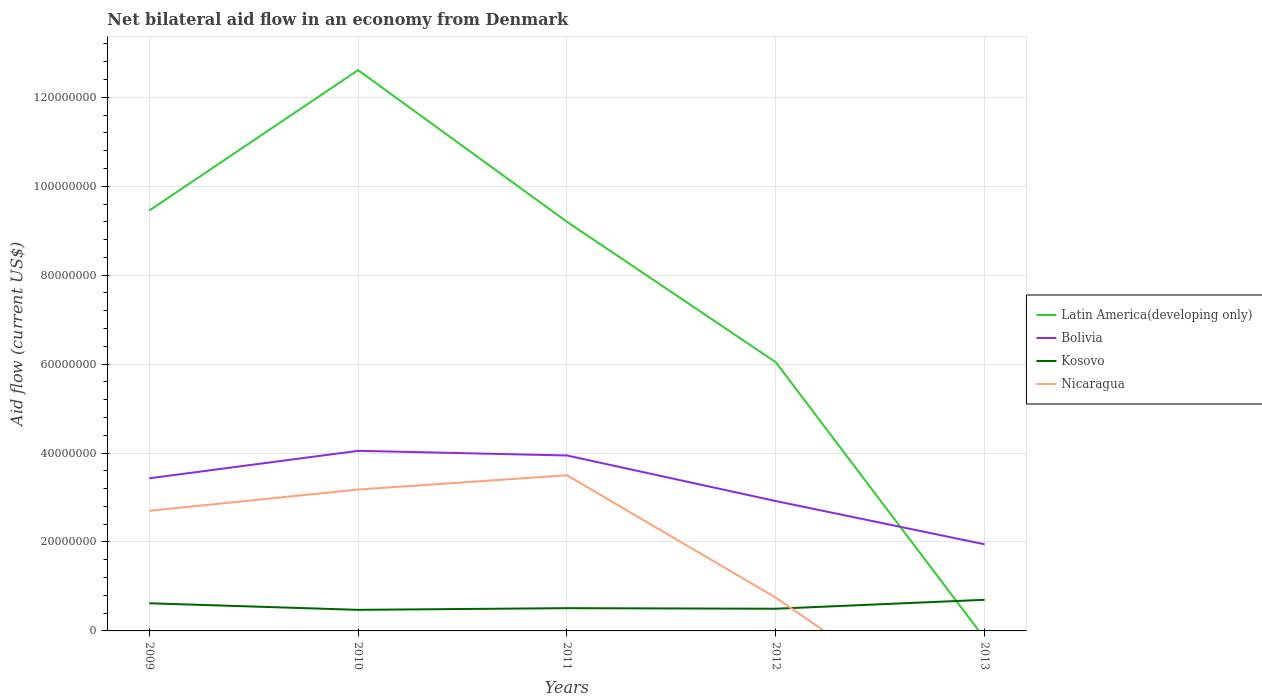Does the line corresponding to Latin America(developing only) intersect with the line corresponding to Nicaragua?
Ensure brevity in your answer.  No. Is the number of lines equal to the number of legend labels?
Your response must be concise. No. Across all years, what is the maximum net bilateral aid flow in Bolivia?
Your response must be concise. 1.95e+07. What is the total net bilateral aid flow in Bolivia in the graph?
Your answer should be compact. 2.00e+07. What is the difference between the highest and the second highest net bilateral aid flow in Kosovo?
Provide a succinct answer. 2.26e+06. What is the difference between the highest and the lowest net bilateral aid flow in Latin America(developing only)?
Offer a terse response. 3. How many lines are there?
Offer a very short reply. 4. How many years are there in the graph?
Offer a terse response. 5. Are the values on the major ticks of Y-axis written in scientific E-notation?
Ensure brevity in your answer.  No. Does the graph contain any zero values?
Offer a very short reply. Yes. How many legend labels are there?
Make the answer very short. 4. How are the legend labels stacked?
Offer a terse response. Vertical. What is the title of the graph?
Your answer should be compact. Net bilateral aid flow in an economy from Denmark. What is the label or title of the X-axis?
Provide a short and direct response. Years. What is the label or title of the Y-axis?
Keep it short and to the point. Aid flow (current US$). What is the Aid flow (current US$) in Latin America(developing only) in 2009?
Ensure brevity in your answer.  9.45e+07. What is the Aid flow (current US$) in Bolivia in 2009?
Your response must be concise. 3.43e+07. What is the Aid flow (current US$) of Kosovo in 2009?
Provide a succinct answer. 6.22e+06. What is the Aid flow (current US$) in Nicaragua in 2009?
Make the answer very short. 2.70e+07. What is the Aid flow (current US$) of Latin America(developing only) in 2010?
Your response must be concise. 1.26e+08. What is the Aid flow (current US$) in Bolivia in 2010?
Give a very brief answer. 4.05e+07. What is the Aid flow (current US$) of Kosovo in 2010?
Make the answer very short. 4.74e+06. What is the Aid flow (current US$) in Nicaragua in 2010?
Offer a very short reply. 3.18e+07. What is the Aid flow (current US$) in Latin America(developing only) in 2011?
Make the answer very short. 9.20e+07. What is the Aid flow (current US$) of Bolivia in 2011?
Your answer should be very brief. 3.94e+07. What is the Aid flow (current US$) of Kosovo in 2011?
Provide a short and direct response. 5.12e+06. What is the Aid flow (current US$) in Nicaragua in 2011?
Make the answer very short. 3.50e+07. What is the Aid flow (current US$) in Latin America(developing only) in 2012?
Provide a succinct answer. 6.04e+07. What is the Aid flow (current US$) of Bolivia in 2012?
Offer a very short reply. 2.92e+07. What is the Aid flow (current US$) of Kosovo in 2012?
Make the answer very short. 4.99e+06. What is the Aid flow (current US$) in Nicaragua in 2012?
Give a very brief answer. 7.48e+06. What is the Aid flow (current US$) of Bolivia in 2013?
Make the answer very short. 1.95e+07. What is the Aid flow (current US$) of Kosovo in 2013?
Give a very brief answer. 7.00e+06. What is the Aid flow (current US$) in Nicaragua in 2013?
Your response must be concise. 0. Across all years, what is the maximum Aid flow (current US$) in Latin America(developing only)?
Offer a very short reply. 1.26e+08. Across all years, what is the maximum Aid flow (current US$) of Bolivia?
Make the answer very short. 4.05e+07. Across all years, what is the maximum Aid flow (current US$) in Nicaragua?
Provide a short and direct response. 3.50e+07. Across all years, what is the minimum Aid flow (current US$) of Bolivia?
Give a very brief answer. 1.95e+07. Across all years, what is the minimum Aid flow (current US$) in Kosovo?
Provide a succinct answer. 4.74e+06. Across all years, what is the minimum Aid flow (current US$) of Nicaragua?
Your answer should be compact. 0. What is the total Aid flow (current US$) in Latin America(developing only) in the graph?
Ensure brevity in your answer.  3.73e+08. What is the total Aid flow (current US$) in Bolivia in the graph?
Provide a short and direct response. 1.63e+08. What is the total Aid flow (current US$) in Kosovo in the graph?
Your answer should be compact. 2.81e+07. What is the total Aid flow (current US$) of Nicaragua in the graph?
Offer a terse response. 1.01e+08. What is the difference between the Aid flow (current US$) in Latin America(developing only) in 2009 and that in 2010?
Offer a very short reply. -3.16e+07. What is the difference between the Aid flow (current US$) in Bolivia in 2009 and that in 2010?
Your answer should be very brief. -6.18e+06. What is the difference between the Aid flow (current US$) in Kosovo in 2009 and that in 2010?
Offer a very short reply. 1.48e+06. What is the difference between the Aid flow (current US$) in Nicaragua in 2009 and that in 2010?
Offer a very short reply. -4.78e+06. What is the difference between the Aid flow (current US$) of Latin America(developing only) in 2009 and that in 2011?
Keep it short and to the point. 2.53e+06. What is the difference between the Aid flow (current US$) in Bolivia in 2009 and that in 2011?
Offer a terse response. -5.13e+06. What is the difference between the Aid flow (current US$) of Kosovo in 2009 and that in 2011?
Your answer should be compact. 1.10e+06. What is the difference between the Aid flow (current US$) of Nicaragua in 2009 and that in 2011?
Give a very brief answer. -7.99e+06. What is the difference between the Aid flow (current US$) of Latin America(developing only) in 2009 and that in 2012?
Ensure brevity in your answer.  3.41e+07. What is the difference between the Aid flow (current US$) of Bolivia in 2009 and that in 2012?
Provide a short and direct response. 5.12e+06. What is the difference between the Aid flow (current US$) of Kosovo in 2009 and that in 2012?
Give a very brief answer. 1.23e+06. What is the difference between the Aid flow (current US$) of Nicaragua in 2009 and that in 2012?
Offer a terse response. 1.95e+07. What is the difference between the Aid flow (current US$) of Bolivia in 2009 and that in 2013?
Offer a terse response. 1.48e+07. What is the difference between the Aid flow (current US$) in Kosovo in 2009 and that in 2013?
Offer a terse response. -7.80e+05. What is the difference between the Aid flow (current US$) of Latin America(developing only) in 2010 and that in 2011?
Give a very brief answer. 3.41e+07. What is the difference between the Aid flow (current US$) of Bolivia in 2010 and that in 2011?
Ensure brevity in your answer.  1.05e+06. What is the difference between the Aid flow (current US$) in Kosovo in 2010 and that in 2011?
Offer a very short reply. -3.80e+05. What is the difference between the Aid flow (current US$) in Nicaragua in 2010 and that in 2011?
Ensure brevity in your answer.  -3.21e+06. What is the difference between the Aid flow (current US$) of Latin America(developing only) in 2010 and that in 2012?
Make the answer very short. 6.57e+07. What is the difference between the Aid flow (current US$) of Bolivia in 2010 and that in 2012?
Offer a terse response. 1.13e+07. What is the difference between the Aid flow (current US$) of Kosovo in 2010 and that in 2012?
Provide a succinct answer. -2.50e+05. What is the difference between the Aid flow (current US$) of Nicaragua in 2010 and that in 2012?
Your answer should be compact. 2.43e+07. What is the difference between the Aid flow (current US$) in Bolivia in 2010 and that in 2013?
Provide a succinct answer. 2.10e+07. What is the difference between the Aid flow (current US$) in Kosovo in 2010 and that in 2013?
Your response must be concise. -2.26e+06. What is the difference between the Aid flow (current US$) of Latin America(developing only) in 2011 and that in 2012?
Offer a terse response. 3.16e+07. What is the difference between the Aid flow (current US$) in Bolivia in 2011 and that in 2012?
Keep it short and to the point. 1.02e+07. What is the difference between the Aid flow (current US$) in Nicaragua in 2011 and that in 2012?
Your answer should be compact. 2.75e+07. What is the difference between the Aid flow (current US$) of Bolivia in 2011 and that in 2013?
Keep it short and to the point. 2.00e+07. What is the difference between the Aid flow (current US$) of Kosovo in 2011 and that in 2013?
Offer a terse response. -1.88e+06. What is the difference between the Aid flow (current US$) of Bolivia in 2012 and that in 2013?
Offer a very short reply. 9.72e+06. What is the difference between the Aid flow (current US$) of Kosovo in 2012 and that in 2013?
Your answer should be very brief. -2.01e+06. What is the difference between the Aid flow (current US$) in Latin America(developing only) in 2009 and the Aid flow (current US$) in Bolivia in 2010?
Provide a short and direct response. 5.40e+07. What is the difference between the Aid flow (current US$) in Latin America(developing only) in 2009 and the Aid flow (current US$) in Kosovo in 2010?
Your answer should be compact. 8.98e+07. What is the difference between the Aid flow (current US$) of Latin America(developing only) in 2009 and the Aid flow (current US$) of Nicaragua in 2010?
Give a very brief answer. 6.27e+07. What is the difference between the Aid flow (current US$) in Bolivia in 2009 and the Aid flow (current US$) in Kosovo in 2010?
Your answer should be very brief. 2.96e+07. What is the difference between the Aid flow (current US$) in Bolivia in 2009 and the Aid flow (current US$) in Nicaragua in 2010?
Your response must be concise. 2.53e+06. What is the difference between the Aid flow (current US$) of Kosovo in 2009 and the Aid flow (current US$) of Nicaragua in 2010?
Offer a very short reply. -2.56e+07. What is the difference between the Aid flow (current US$) of Latin America(developing only) in 2009 and the Aid flow (current US$) of Bolivia in 2011?
Make the answer very short. 5.51e+07. What is the difference between the Aid flow (current US$) in Latin America(developing only) in 2009 and the Aid flow (current US$) in Kosovo in 2011?
Provide a short and direct response. 8.94e+07. What is the difference between the Aid flow (current US$) in Latin America(developing only) in 2009 and the Aid flow (current US$) in Nicaragua in 2011?
Offer a terse response. 5.95e+07. What is the difference between the Aid flow (current US$) in Bolivia in 2009 and the Aid flow (current US$) in Kosovo in 2011?
Keep it short and to the point. 2.92e+07. What is the difference between the Aid flow (current US$) in Bolivia in 2009 and the Aid flow (current US$) in Nicaragua in 2011?
Make the answer very short. -6.80e+05. What is the difference between the Aid flow (current US$) of Kosovo in 2009 and the Aid flow (current US$) of Nicaragua in 2011?
Give a very brief answer. -2.88e+07. What is the difference between the Aid flow (current US$) of Latin America(developing only) in 2009 and the Aid flow (current US$) of Bolivia in 2012?
Make the answer very short. 6.53e+07. What is the difference between the Aid flow (current US$) of Latin America(developing only) in 2009 and the Aid flow (current US$) of Kosovo in 2012?
Keep it short and to the point. 8.95e+07. What is the difference between the Aid flow (current US$) in Latin America(developing only) in 2009 and the Aid flow (current US$) in Nicaragua in 2012?
Provide a succinct answer. 8.70e+07. What is the difference between the Aid flow (current US$) of Bolivia in 2009 and the Aid flow (current US$) of Kosovo in 2012?
Provide a succinct answer. 2.93e+07. What is the difference between the Aid flow (current US$) of Bolivia in 2009 and the Aid flow (current US$) of Nicaragua in 2012?
Keep it short and to the point. 2.68e+07. What is the difference between the Aid flow (current US$) in Kosovo in 2009 and the Aid flow (current US$) in Nicaragua in 2012?
Offer a terse response. -1.26e+06. What is the difference between the Aid flow (current US$) in Latin America(developing only) in 2009 and the Aid flow (current US$) in Bolivia in 2013?
Your answer should be very brief. 7.50e+07. What is the difference between the Aid flow (current US$) in Latin America(developing only) in 2009 and the Aid flow (current US$) in Kosovo in 2013?
Ensure brevity in your answer.  8.75e+07. What is the difference between the Aid flow (current US$) of Bolivia in 2009 and the Aid flow (current US$) of Kosovo in 2013?
Your response must be concise. 2.73e+07. What is the difference between the Aid flow (current US$) of Latin America(developing only) in 2010 and the Aid flow (current US$) of Bolivia in 2011?
Your answer should be very brief. 8.66e+07. What is the difference between the Aid flow (current US$) of Latin America(developing only) in 2010 and the Aid flow (current US$) of Kosovo in 2011?
Provide a succinct answer. 1.21e+08. What is the difference between the Aid flow (current US$) of Latin America(developing only) in 2010 and the Aid flow (current US$) of Nicaragua in 2011?
Provide a short and direct response. 9.11e+07. What is the difference between the Aid flow (current US$) in Bolivia in 2010 and the Aid flow (current US$) in Kosovo in 2011?
Your answer should be very brief. 3.54e+07. What is the difference between the Aid flow (current US$) of Bolivia in 2010 and the Aid flow (current US$) of Nicaragua in 2011?
Your answer should be very brief. 5.50e+06. What is the difference between the Aid flow (current US$) in Kosovo in 2010 and the Aid flow (current US$) in Nicaragua in 2011?
Give a very brief answer. -3.03e+07. What is the difference between the Aid flow (current US$) in Latin America(developing only) in 2010 and the Aid flow (current US$) in Bolivia in 2012?
Offer a terse response. 9.69e+07. What is the difference between the Aid flow (current US$) in Latin America(developing only) in 2010 and the Aid flow (current US$) in Kosovo in 2012?
Provide a short and direct response. 1.21e+08. What is the difference between the Aid flow (current US$) in Latin America(developing only) in 2010 and the Aid flow (current US$) in Nicaragua in 2012?
Ensure brevity in your answer.  1.19e+08. What is the difference between the Aid flow (current US$) of Bolivia in 2010 and the Aid flow (current US$) of Kosovo in 2012?
Your answer should be very brief. 3.55e+07. What is the difference between the Aid flow (current US$) of Bolivia in 2010 and the Aid flow (current US$) of Nicaragua in 2012?
Your answer should be compact. 3.30e+07. What is the difference between the Aid flow (current US$) in Kosovo in 2010 and the Aid flow (current US$) in Nicaragua in 2012?
Your answer should be very brief. -2.74e+06. What is the difference between the Aid flow (current US$) in Latin America(developing only) in 2010 and the Aid flow (current US$) in Bolivia in 2013?
Offer a very short reply. 1.07e+08. What is the difference between the Aid flow (current US$) in Latin America(developing only) in 2010 and the Aid flow (current US$) in Kosovo in 2013?
Give a very brief answer. 1.19e+08. What is the difference between the Aid flow (current US$) in Bolivia in 2010 and the Aid flow (current US$) in Kosovo in 2013?
Ensure brevity in your answer.  3.35e+07. What is the difference between the Aid flow (current US$) of Latin America(developing only) in 2011 and the Aid flow (current US$) of Bolivia in 2012?
Your response must be concise. 6.28e+07. What is the difference between the Aid flow (current US$) of Latin America(developing only) in 2011 and the Aid flow (current US$) of Kosovo in 2012?
Your response must be concise. 8.70e+07. What is the difference between the Aid flow (current US$) in Latin America(developing only) in 2011 and the Aid flow (current US$) in Nicaragua in 2012?
Offer a terse response. 8.45e+07. What is the difference between the Aid flow (current US$) of Bolivia in 2011 and the Aid flow (current US$) of Kosovo in 2012?
Offer a terse response. 3.45e+07. What is the difference between the Aid flow (current US$) in Bolivia in 2011 and the Aid flow (current US$) in Nicaragua in 2012?
Offer a very short reply. 3.20e+07. What is the difference between the Aid flow (current US$) of Kosovo in 2011 and the Aid flow (current US$) of Nicaragua in 2012?
Offer a very short reply. -2.36e+06. What is the difference between the Aid flow (current US$) of Latin America(developing only) in 2011 and the Aid flow (current US$) of Bolivia in 2013?
Offer a terse response. 7.25e+07. What is the difference between the Aid flow (current US$) in Latin America(developing only) in 2011 and the Aid flow (current US$) in Kosovo in 2013?
Provide a short and direct response. 8.50e+07. What is the difference between the Aid flow (current US$) of Bolivia in 2011 and the Aid flow (current US$) of Kosovo in 2013?
Provide a succinct answer. 3.24e+07. What is the difference between the Aid flow (current US$) of Latin America(developing only) in 2012 and the Aid flow (current US$) of Bolivia in 2013?
Make the answer very short. 4.09e+07. What is the difference between the Aid flow (current US$) in Latin America(developing only) in 2012 and the Aid flow (current US$) in Kosovo in 2013?
Offer a terse response. 5.34e+07. What is the difference between the Aid flow (current US$) in Bolivia in 2012 and the Aid flow (current US$) in Kosovo in 2013?
Provide a succinct answer. 2.22e+07. What is the average Aid flow (current US$) of Latin America(developing only) per year?
Offer a very short reply. 7.46e+07. What is the average Aid flow (current US$) of Bolivia per year?
Your response must be concise. 3.26e+07. What is the average Aid flow (current US$) in Kosovo per year?
Your response must be concise. 5.61e+06. What is the average Aid flow (current US$) in Nicaragua per year?
Provide a short and direct response. 2.03e+07. In the year 2009, what is the difference between the Aid flow (current US$) of Latin America(developing only) and Aid flow (current US$) of Bolivia?
Ensure brevity in your answer.  6.02e+07. In the year 2009, what is the difference between the Aid flow (current US$) of Latin America(developing only) and Aid flow (current US$) of Kosovo?
Make the answer very short. 8.83e+07. In the year 2009, what is the difference between the Aid flow (current US$) of Latin America(developing only) and Aid flow (current US$) of Nicaragua?
Give a very brief answer. 6.75e+07. In the year 2009, what is the difference between the Aid flow (current US$) of Bolivia and Aid flow (current US$) of Kosovo?
Offer a terse response. 2.81e+07. In the year 2009, what is the difference between the Aid flow (current US$) of Bolivia and Aid flow (current US$) of Nicaragua?
Your answer should be very brief. 7.31e+06. In the year 2009, what is the difference between the Aid flow (current US$) of Kosovo and Aid flow (current US$) of Nicaragua?
Your answer should be very brief. -2.08e+07. In the year 2010, what is the difference between the Aid flow (current US$) of Latin America(developing only) and Aid flow (current US$) of Bolivia?
Keep it short and to the point. 8.56e+07. In the year 2010, what is the difference between the Aid flow (current US$) of Latin America(developing only) and Aid flow (current US$) of Kosovo?
Ensure brevity in your answer.  1.21e+08. In the year 2010, what is the difference between the Aid flow (current US$) of Latin America(developing only) and Aid flow (current US$) of Nicaragua?
Offer a terse response. 9.43e+07. In the year 2010, what is the difference between the Aid flow (current US$) of Bolivia and Aid flow (current US$) of Kosovo?
Your answer should be compact. 3.58e+07. In the year 2010, what is the difference between the Aid flow (current US$) in Bolivia and Aid flow (current US$) in Nicaragua?
Provide a short and direct response. 8.71e+06. In the year 2010, what is the difference between the Aid flow (current US$) in Kosovo and Aid flow (current US$) in Nicaragua?
Your answer should be compact. -2.70e+07. In the year 2011, what is the difference between the Aid flow (current US$) in Latin America(developing only) and Aid flow (current US$) in Bolivia?
Provide a short and direct response. 5.26e+07. In the year 2011, what is the difference between the Aid flow (current US$) of Latin America(developing only) and Aid flow (current US$) of Kosovo?
Your answer should be very brief. 8.69e+07. In the year 2011, what is the difference between the Aid flow (current US$) of Latin America(developing only) and Aid flow (current US$) of Nicaragua?
Provide a succinct answer. 5.70e+07. In the year 2011, what is the difference between the Aid flow (current US$) of Bolivia and Aid flow (current US$) of Kosovo?
Your answer should be compact. 3.43e+07. In the year 2011, what is the difference between the Aid flow (current US$) of Bolivia and Aid flow (current US$) of Nicaragua?
Offer a very short reply. 4.45e+06. In the year 2011, what is the difference between the Aid flow (current US$) of Kosovo and Aid flow (current US$) of Nicaragua?
Your answer should be very brief. -2.99e+07. In the year 2012, what is the difference between the Aid flow (current US$) in Latin America(developing only) and Aid flow (current US$) in Bolivia?
Make the answer very short. 3.12e+07. In the year 2012, what is the difference between the Aid flow (current US$) in Latin America(developing only) and Aid flow (current US$) in Kosovo?
Make the answer very short. 5.54e+07. In the year 2012, what is the difference between the Aid flow (current US$) in Latin America(developing only) and Aid flow (current US$) in Nicaragua?
Give a very brief answer. 5.29e+07. In the year 2012, what is the difference between the Aid flow (current US$) in Bolivia and Aid flow (current US$) in Kosovo?
Provide a succinct answer. 2.42e+07. In the year 2012, what is the difference between the Aid flow (current US$) in Bolivia and Aid flow (current US$) in Nicaragua?
Keep it short and to the point. 2.17e+07. In the year 2012, what is the difference between the Aid flow (current US$) in Kosovo and Aid flow (current US$) in Nicaragua?
Ensure brevity in your answer.  -2.49e+06. In the year 2013, what is the difference between the Aid flow (current US$) in Bolivia and Aid flow (current US$) in Kosovo?
Your answer should be very brief. 1.25e+07. What is the ratio of the Aid flow (current US$) of Latin America(developing only) in 2009 to that in 2010?
Give a very brief answer. 0.75. What is the ratio of the Aid flow (current US$) of Bolivia in 2009 to that in 2010?
Make the answer very short. 0.85. What is the ratio of the Aid flow (current US$) in Kosovo in 2009 to that in 2010?
Offer a very short reply. 1.31. What is the ratio of the Aid flow (current US$) in Nicaragua in 2009 to that in 2010?
Ensure brevity in your answer.  0.85. What is the ratio of the Aid flow (current US$) in Latin America(developing only) in 2009 to that in 2011?
Provide a short and direct response. 1.03. What is the ratio of the Aid flow (current US$) of Bolivia in 2009 to that in 2011?
Your answer should be compact. 0.87. What is the ratio of the Aid flow (current US$) of Kosovo in 2009 to that in 2011?
Provide a succinct answer. 1.21. What is the ratio of the Aid flow (current US$) in Nicaragua in 2009 to that in 2011?
Your response must be concise. 0.77. What is the ratio of the Aid flow (current US$) in Latin America(developing only) in 2009 to that in 2012?
Offer a terse response. 1.56. What is the ratio of the Aid flow (current US$) of Bolivia in 2009 to that in 2012?
Ensure brevity in your answer.  1.18. What is the ratio of the Aid flow (current US$) of Kosovo in 2009 to that in 2012?
Your response must be concise. 1.25. What is the ratio of the Aid flow (current US$) of Nicaragua in 2009 to that in 2012?
Give a very brief answer. 3.61. What is the ratio of the Aid flow (current US$) of Bolivia in 2009 to that in 2013?
Your answer should be compact. 1.76. What is the ratio of the Aid flow (current US$) of Kosovo in 2009 to that in 2013?
Make the answer very short. 0.89. What is the ratio of the Aid flow (current US$) in Latin America(developing only) in 2010 to that in 2011?
Your answer should be compact. 1.37. What is the ratio of the Aid flow (current US$) of Bolivia in 2010 to that in 2011?
Provide a succinct answer. 1.03. What is the ratio of the Aid flow (current US$) of Kosovo in 2010 to that in 2011?
Offer a very short reply. 0.93. What is the ratio of the Aid flow (current US$) in Nicaragua in 2010 to that in 2011?
Make the answer very short. 0.91. What is the ratio of the Aid flow (current US$) in Latin America(developing only) in 2010 to that in 2012?
Provide a succinct answer. 2.09. What is the ratio of the Aid flow (current US$) of Bolivia in 2010 to that in 2012?
Offer a terse response. 1.39. What is the ratio of the Aid flow (current US$) in Kosovo in 2010 to that in 2012?
Ensure brevity in your answer.  0.95. What is the ratio of the Aid flow (current US$) of Nicaragua in 2010 to that in 2012?
Your response must be concise. 4.25. What is the ratio of the Aid flow (current US$) in Bolivia in 2010 to that in 2013?
Your response must be concise. 2.08. What is the ratio of the Aid flow (current US$) of Kosovo in 2010 to that in 2013?
Provide a succinct answer. 0.68. What is the ratio of the Aid flow (current US$) of Latin America(developing only) in 2011 to that in 2012?
Your answer should be very brief. 1.52. What is the ratio of the Aid flow (current US$) of Bolivia in 2011 to that in 2012?
Offer a terse response. 1.35. What is the ratio of the Aid flow (current US$) in Kosovo in 2011 to that in 2012?
Provide a succinct answer. 1.03. What is the ratio of the Aid flow (current US$) of Nicaragua in 2011 to that in 2012?
Give a very brief answer. 4.68. What is the ratio of the Aid flow (current US$) in Bolivia in 2011 to that in 2013?
Make the answer very short. 2.03. What is the ratio of the Aid flow (current US$) of Kosovo in 2011 to that in 2013?
Your answer should be compact. 0.73. What is the ratio of the Aid flow (current US$) of Bolivia in 2012 to that in 2013?
Your answer should be very brief. 1.5. What is the ratio of the Aid flow (current US$) of Kosovo in 2012 to that in 2013?
Make the answer very short. 0.71. What is the difference between the highest and the second highest Aid flow (current US$) in Latin America(developing only)?
Ensure brevity in your answer.  3.16e+07. What is the difference between the highest and the second highest Aid flow (current US$) in Bolivia?
Provide a succinct answer. 1.05e+06. What is the difference between the highest and the second highest Aid flow (current US$) in Kosovo?
Offer a terse response. 7.80e+05. What is the difference between the highest and the second highest Aid flow (current US$) in Nicaragua?
Provide a succinct answer. 3.21e+06. What is the difference between the highest and the lowest Aid flow (current US$) in Latin America(developing only)?
Your answer should be compact. 1.26e+08. What is the difference between the highest and the lowest Aid flow (current US$) in Bolivia?
Your answer should be very brief. 2.10e+07. What is the difference between the highest and the lowest Aid flow (current US$) of Kosovo?
Offer a very short reply. 2.26e+06. What is the difference between the highest and the lowest Aid flow (current US$) of Nicaragua?
Offer a very short reply. 3.50e+07. 